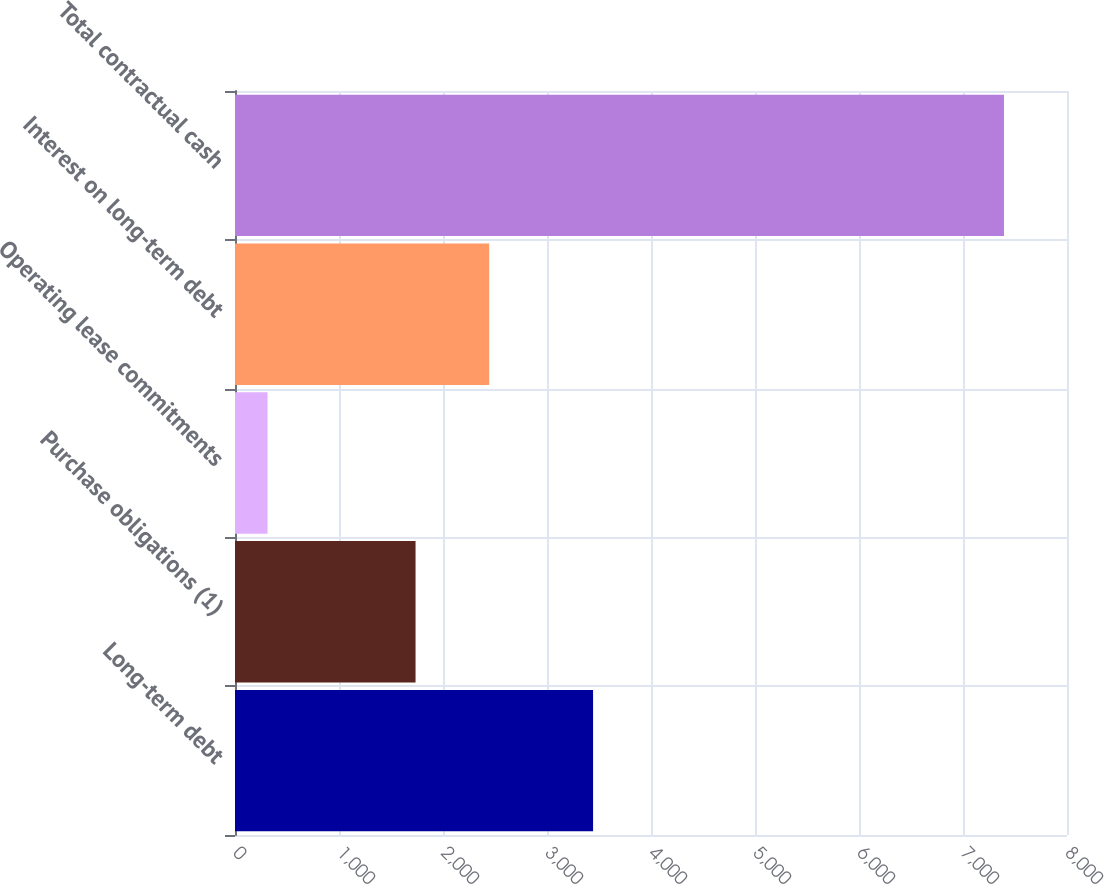<chart> <loc_0><loc_0><loc_500><loc_500><bar_chart><fcel>Long-term debt<fcel>Purchase obligations (1)<fcel>Operating lease commitments<fcel>Interest on long-term debt<fcel>Total contractual cash<nl><fcel>3443<fcel>1736<fcel>313<fcel>2444.1<fcel>7394<nl></chart> 